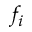Convert formula to latex. <formula><loc_0><loc_0><loc_500><loc_500>f _ { i }</formula> 